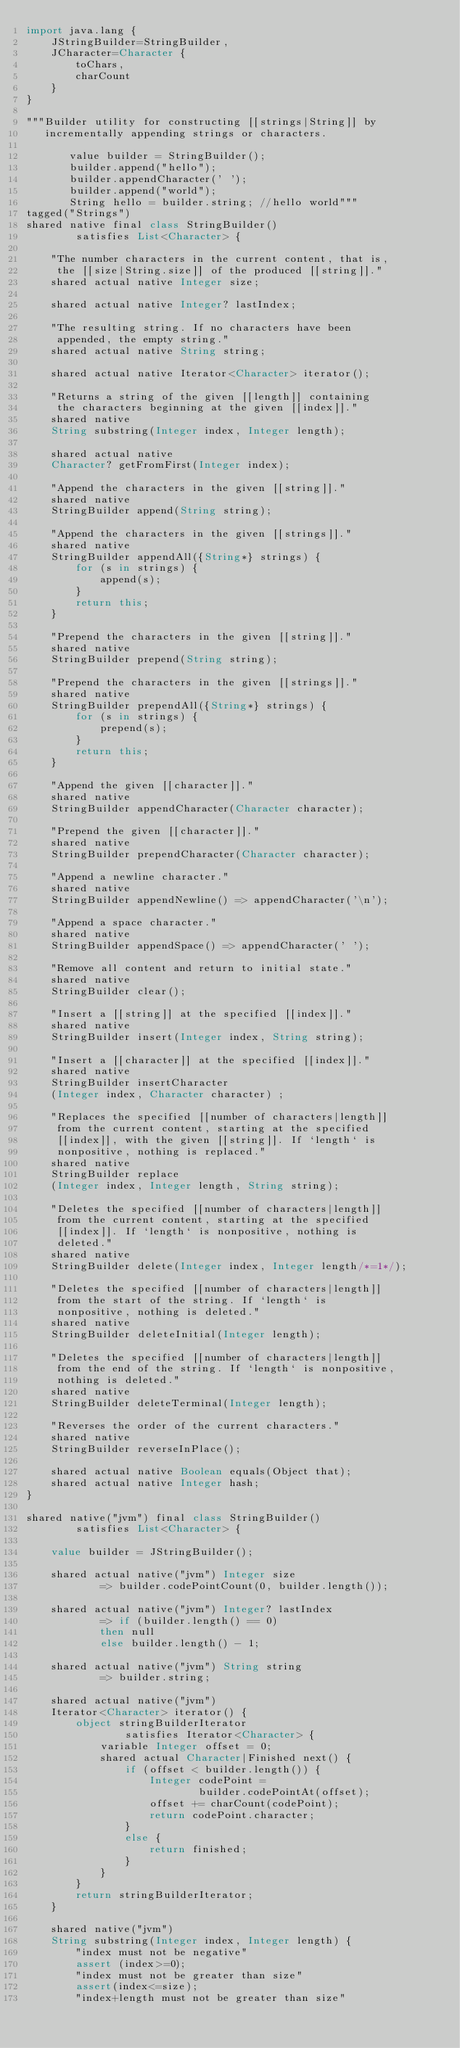Convert code to text. <code><loc_0><loc_0><loc_500><loc_500><_Ceylon_>import java.lang {
    JStringBuilder=StringBuilder,
    JCharacter=Character {
        toChars,
        charCount
    }
}

"""Builder utility for constructing [[strings|String]] by 
   incrementally appending strings or characters.
   
       value builder = StringBuilder();
       builder.append("hello");
       builder.appendCharacter(' ');
       builder.append("world");
       String hello = builder.string; //hello world"""
tagged("Strings")
shared native final class StringBuilder() 
        satisfies List<Character> {
    
    "The number characters in the current content, that is, 
     the [[size|String.size]] of the produced [[string]]."
    shared actual native Integer size;
    
    shared actual native Integer? lastIndex;
    
    "The resulting string. If no characters have been
     appended, the empty string."
    shared actual native String string;
    
    shared actual native Iterator<Character> iterator();
    
    "Returns a string of the given [[length]] containing
     the characters beginning at the given [[index]]."
    shared native 
    String substring(Integer index, Integer length);
    
    shared actual native
    Character? getFromFirst(Integer index);
    
    "Append the characters in the given [[string]]."
    shared native 
    StringBuilder append(String string);
    
    "Append the characters in the given [[strings]]."
    shared native 
    StringBuilder appendAll({String*} strings) {
        for (s in strings) {
            append(s);
        }
        return this;
    }
    
    "Prepend the characters in the given [[string]]."
    shared native 
    StringBuilder prepend(String string);
    
    "Prepend the characters in the given [[strings]]."
    shared native 
    StringBuilder prependAll({String*} strings) {
        for (s in strings) {
            prepend(s);
        }
        return this;
    }
    
    "Append the given [[character]]."
    shared native 
    StringBuilder appendCharacter(Character character);
    
    "Prepend the given [[character]]."
    shared native 
    StringBuilder prependCharacter(Character character);
    
    "Append a newline character."
    shared native 
    StringBuilder appendNewline() => appendCharacter('\n');
    
    "Append a space character."
    shared native 
    StringBuilder appendSpace() => appendCharacter(' ');
    
    "Remove all content and return to initial state."
    shared native 
    StringBuilder clear();
    
    "Insert a [[string]] at the specified [[index]]."
    shared native 
    StringBuilder insert(Integer index, String string);
    
    "Insert a [[character]] at the specified [[index]]."
    shared native 
    StringBuilder insertCharacter
    (Integer index, Character character) ;
    
    "Replaces the specified [[number of characters|length]] 
     from the current content, starting at the specified 
     [[index]], with the given [[string]]. If `length` is 
     nonpositive, nothing is replaced."
    shared native 
    StringBuilder replace
    (Integer index, Integer length, String string);
    
    "Deletes the specified [[number of characters|length]] 
     from the current content, starting at the specified 
     [[index]]. If `length` is nonpositive, nothing is 
     deleted."
    shared native 
    StringBuilder delete(Integer index, Integer length/*=1*/);
    
    "Deletes the specified [[number of characters|length]] 
     from the start of the string. If `length` is 
     nonpositive, nothing is deleted."
    shared native 
    StringBuilder deleteInitial(Integer length);
    
    "Deletes the specified [[number of characters|length]] 
     from the end of the string. If `length` is nonpositive, 
     nothing is deleted."
    shared native 
    StringBuilder deleteTerminal(Integer length);
    
    "Reverses the order of the current characters."
    shared native 
    StringBuilder reverseInPlace();
    
    shared actual native Boolean equals(Object that);
    shared actual native Integer hash;
}

shared native("jvm") final class StringBuilder() 
        satisfies List<Character> {
    
    value builder = JStringBuilder();
    
    shared actual native("jvm") Integer size 
            => builder.codePointCount(0, builder.length());
    
    shared actual native("jvm") Integer? lastIndex 
            => if (builder.length() == 0)
            then null
            else builder.length() - 1;
    
    shared actual native("jvm") String string 
            => builder.string;
    
    shared actual native("jvm") 
    Iterator<Character> iterator() {
        object stringBuilderIterator
                satisfies Iterator<Character> {
            variable Integer offset = 0;
            shared actual Character|Finished next() {
                if (offset < builder.length()) {
                    Integer codePoint = 
                            builder.codePointAt(offset);
                    offset += charCount(codePoint);
                    return codePoint.character;
                }
                else {
                    return finished;
                }
            }
        }
        return stringBuilderIterator;
    }
    
    shared native("jvm") 
    String substring(Integer index, Integer length) {
        "index must not be negative"
        assert (index>=0);
        "index must not be greater than size"
        assert(index<=size);
        "index+length must not be greater than size"</code> 